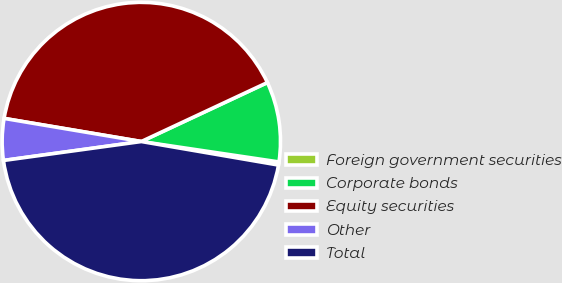Convert chart. <chart><loc_0><loc_0><loc_500><loc_500><pie_chart><fcel>Foreign government securities<fcel>Corporate bonds<fcel>Equity securities<fcel>Other<fcel>Total<nl><fcel>0.36%<fcel>9.31%<fcel>40.38%<fcel>4.83%<fcel>45.12%<nl></chart> 